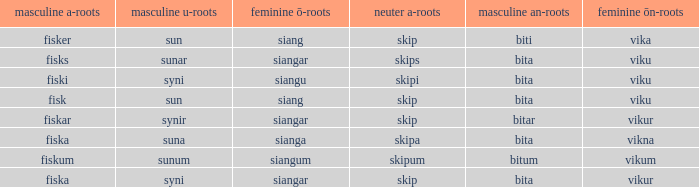Write the full table. {'header': ['masculine a-roots', 'masculine u-roots', 'feminine ō-roots', 'neuter a-roots', 'masculine an-roots', 'feminine ōn-roots'], 'rows': [['fisker', 'sun', 'siang', 'skip', 'biti', 'vika'], ['fisks', 'sunar', 'siangar', 'skips', 'bita', 'viku'], ['fiski', 'syni', 'siangu', 'skipi', 'bita', 'viku'], ['fisk', 'sun', 'siang', 'skip', 'bita', 'viku'], ['fiskar', 'synir', 'siangar', 'skip', 'bitar', 'vikur'], ['fiska', 'suna', 'sianga', 'skipa', 'bita', 'vikna'], ['fiskum', 'sunum', 'siangum', 'skipum', 'bitum', 'vikum'], ['fiska', 'syni', 'siangar', 'skip', 'bita', 'vikur']]} What is the u form of the word with a neuter form of skip and a masculine a-ending of fisker? Sun. 